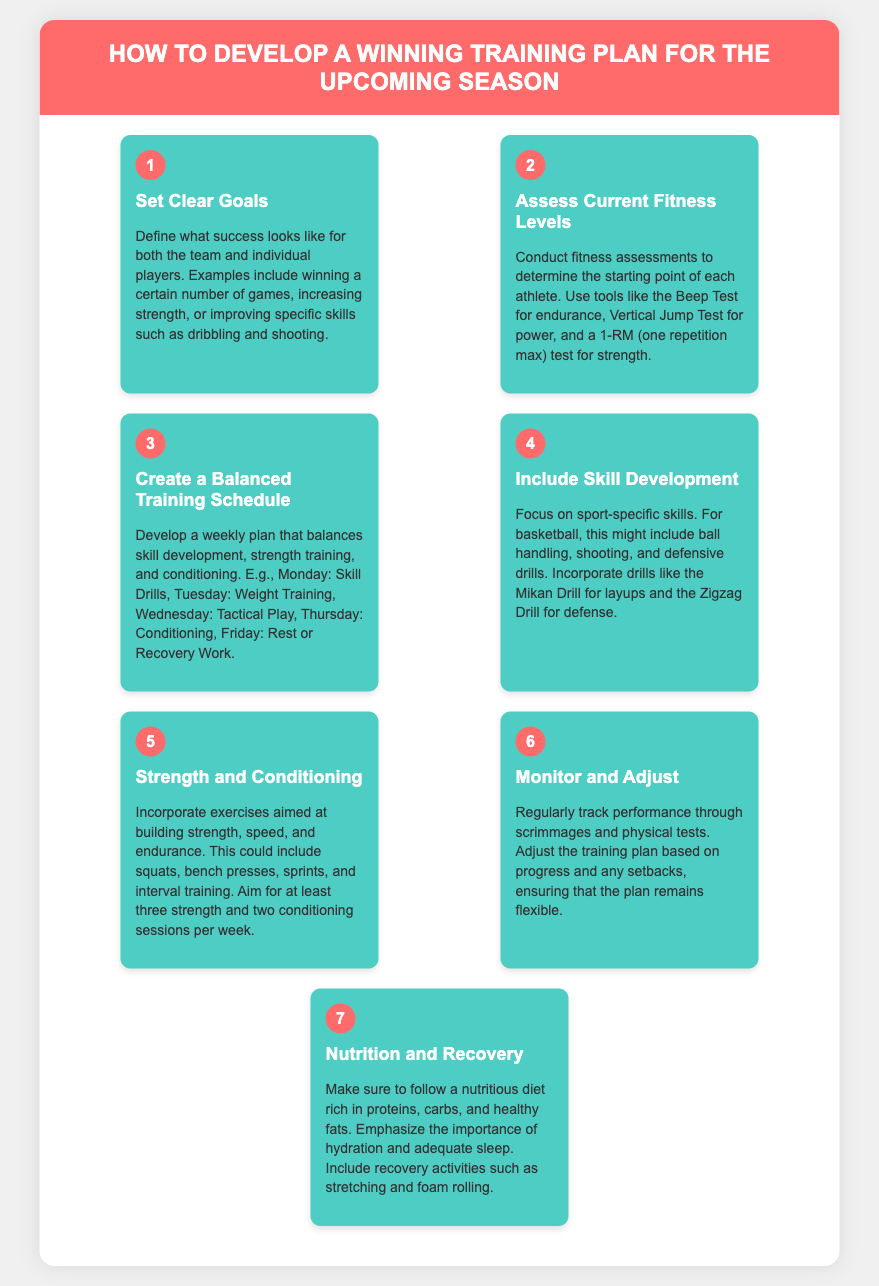what is the first step in developing a training plan? The first step is to set clear goals for both the team and individual players.
Answer: Set Clear Goals how many strength and conditioning sessions should be included per week? The document states to aim for at least three strength and two conditioning sessions per week.
Answer: Three strength and two conditioning what type of drills might be included for basketball skill development? The document mentions ball handling, shooting, and defensive drills as examples of sport-specific skills.
Answer: Ball handling, shooting, and defensive drills what is the focus of the second step in the training plan? The second step focuses on assessing the current fitness levels of each athlete.
Answer: Assess Current Fitness Levels what is a suggested activity on Monday in the training schedule? The document suggests skill drills as the activity for Monday.
Answer: Skill Drills what should be monitored and adjusted throughout the training process? The document mentions that performance should be monitored and adjustments made based on progress and setbacks.
Answer: Performance which two aspects of nutrition are emphasized in the training plan? The document emphasizes hydration and adequate sleep as key components of nutrition and recovery.
Answer: Hydration and adequate sleep what does the fifth step focus on regarding physical fitness? The fifth step focuses on incorporating exercises aimed at building strength, speed, and endurance.
Answer: Strength, speed, and endurance 